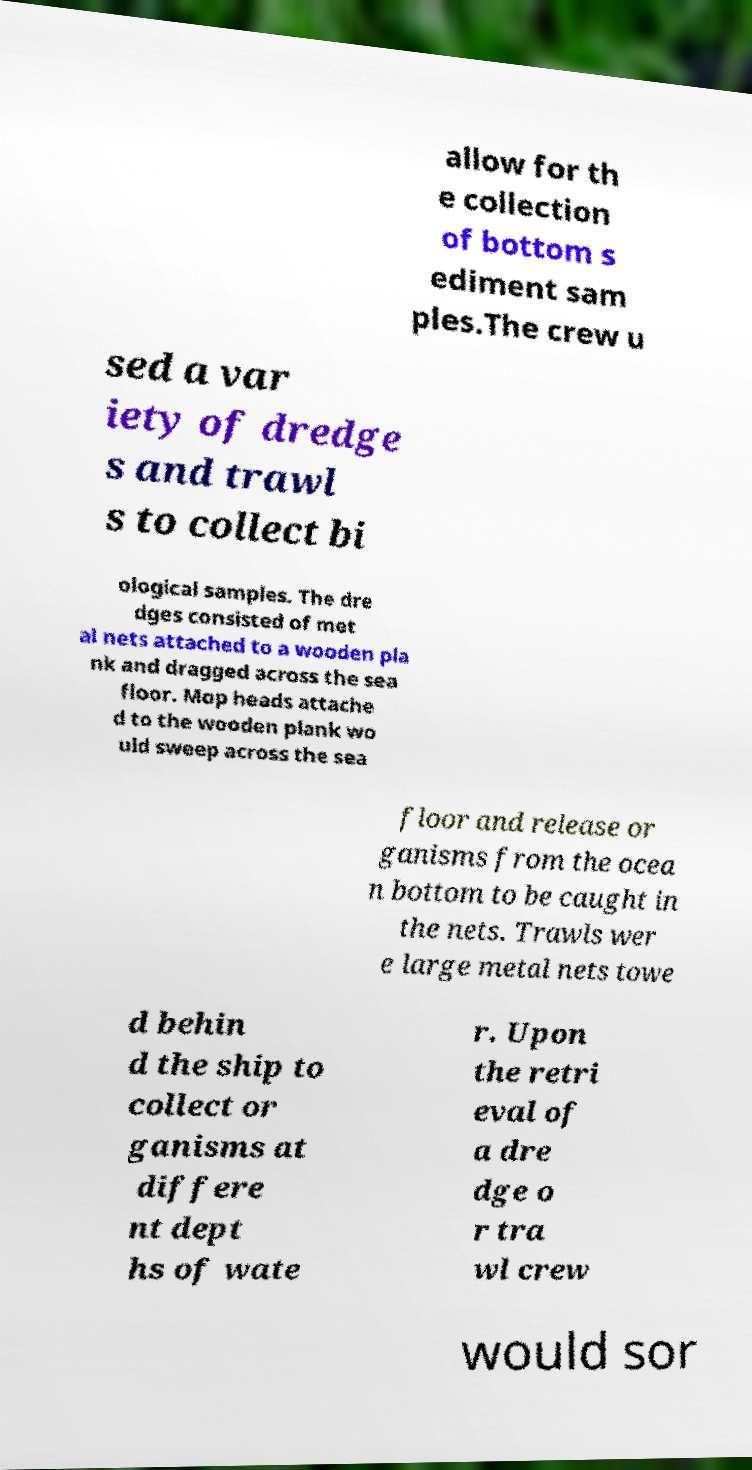Please identify and transcribe the text found in this image. allow for th e collection of bottom s ediment sam ples.The crew u sed a var iety of dredge s and trawl s to collect bi ological samples. The dre dges consisted of met al nets attached to a wooden pla nk and dragged across the sea floor. Mop heads attache d to the wooden plank wo uld sweep across the sea floor and release or ganisms from the ocea n bottom to be caught in the nets. Trawls wer e large metal nets towe d behin d the ship to collect or ganisms at differe nt dept hs of wate r. Upon the retri eval of a dre dge o r tra wl crew would sor 